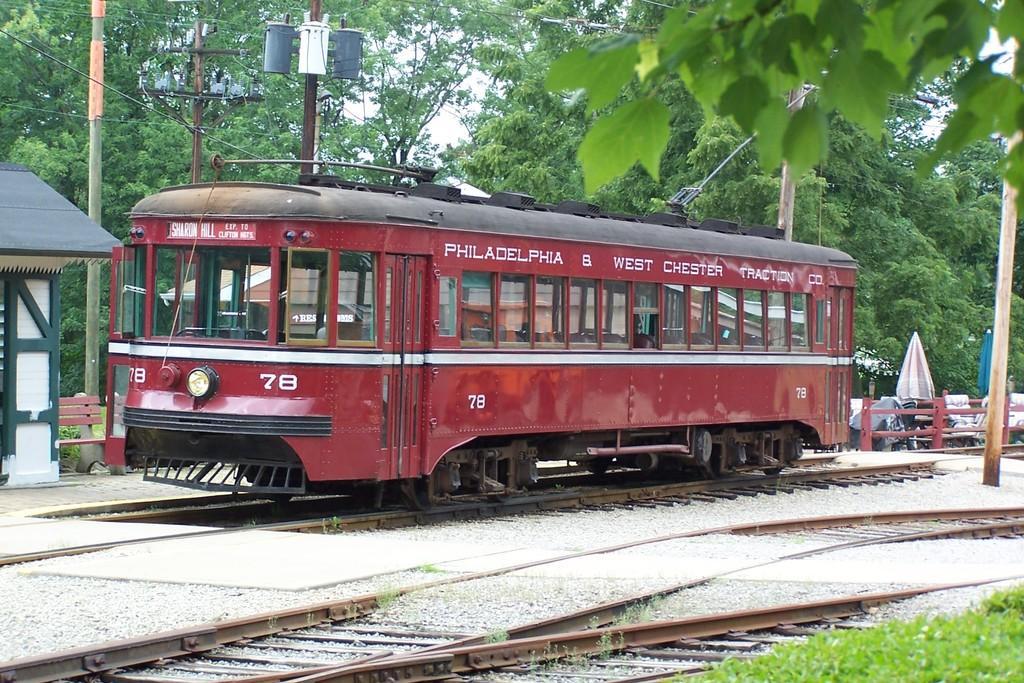Please provide a concise description of this image. In this picture we can see a train on a railway track, fence, umbrellas, poles, bench, shade, trees, grass and in the background we can see the sky. 